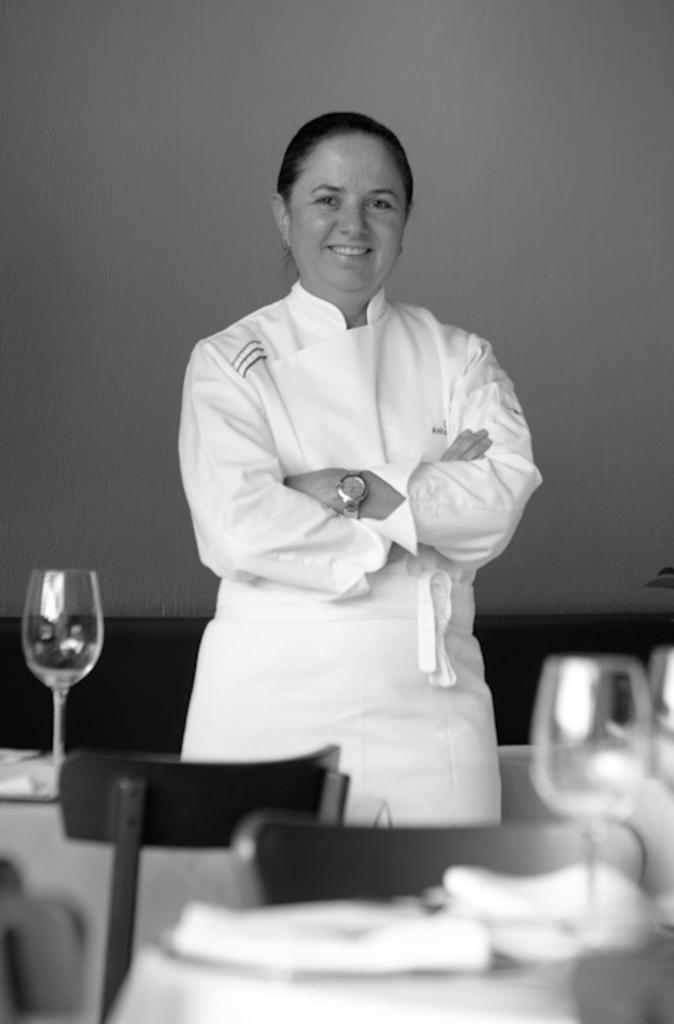What is the person in the image wearing? The person in the image is wearing a white costume. What can be seen on the table in the image? There are objects on a table, including a glass. What type of furniture is visible in the image? There are chairs visible in the image. What is the background of the image? There is a wall in the image. What type of vegetable is being used as a decoration on the wall in the image? There is no vegetable present on the wall in the image. 